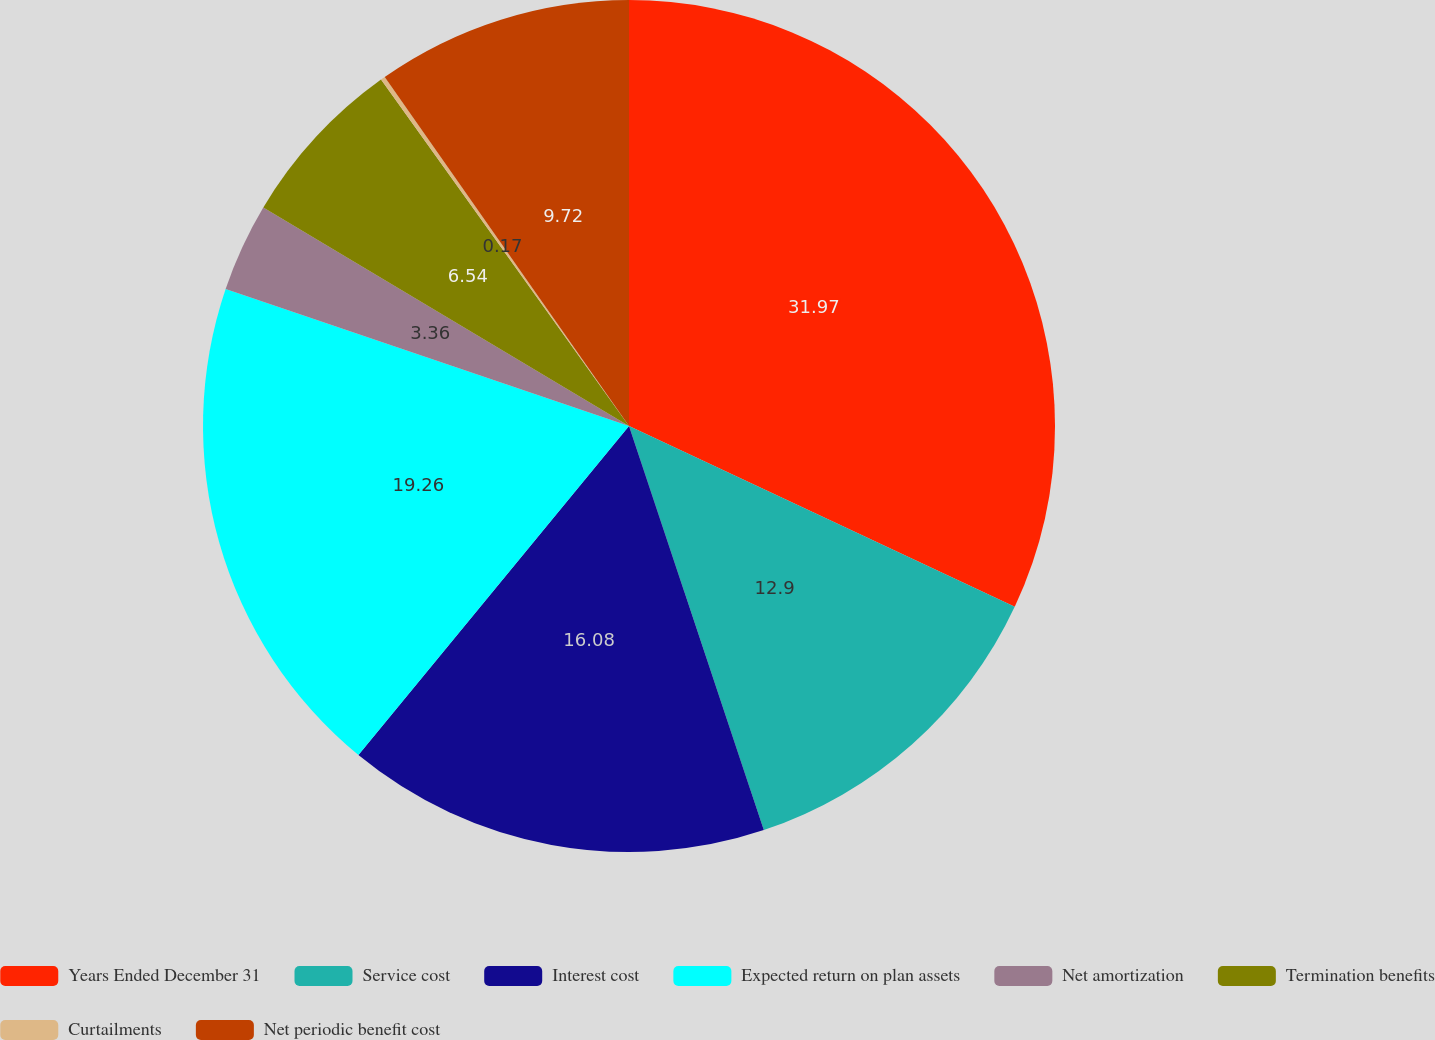<chart> <loc_0><loc_0><loc_500><loc_500><pie_chart><fcel>Years Ended December 31<fcel>Service cost<fcel>Interest cost<fcel>Expected return on plan assets<fcel>Net amortization<fcel>Termination benefits<fcel>Curtailments<fcel>Net periodic benefit cost<nl><fcel>31.98%<fcel>12.9%<fcel>16.08%<fcel>19.26%<fcel>3.36%<fcel>6.54%<fcel>0.17%<fcel>9.72%<nl></chart> 